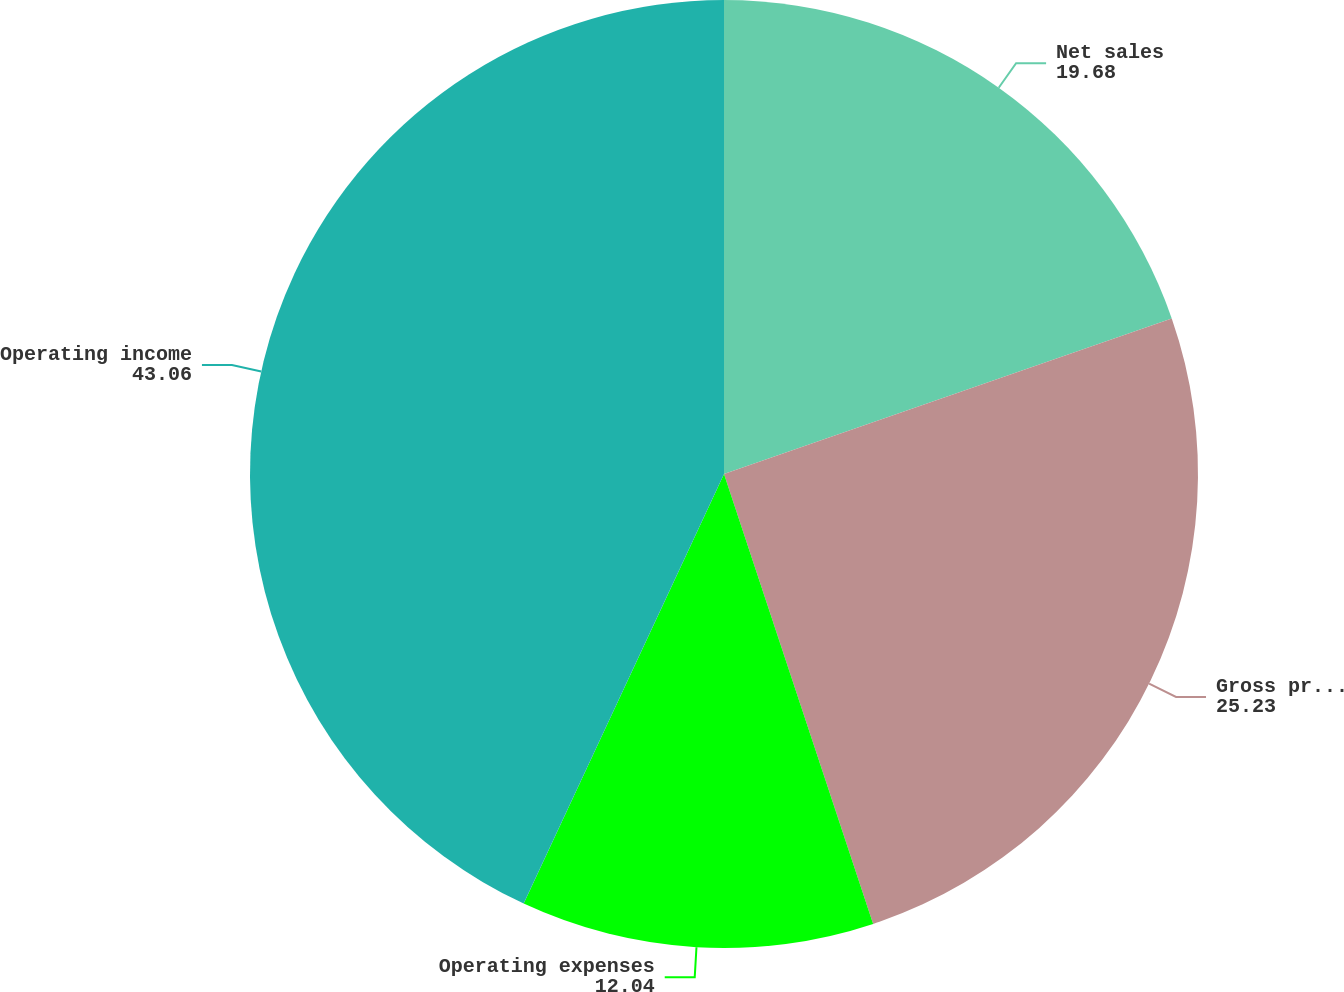Convert chart to OTSL. <chart><loc_0><loc_0><loc_500><loc_500><pie_chart><fcel>Net sales<fcel>Gross profit<fcel>Operating expenses<fcel>Operating income<nl><fcel>19.68%<fcel>25.23%<fcel>12.04%<fcel>43.06%<nl></chart> 